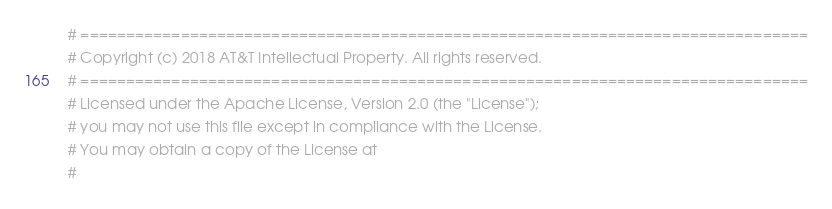<code> <loc_0><loc_0><loc_500><loc_500><_Python_># ================================================================================
# Copyright (c) 2018 AT&T Intellectual Property. All rights reserved.
# ================================================================================
# Licensed under the Apache License, Version 2.0 (the "License");
# you may not use this file except in compliance with the License.
# You may obtain a copy of the License at
#</code> 